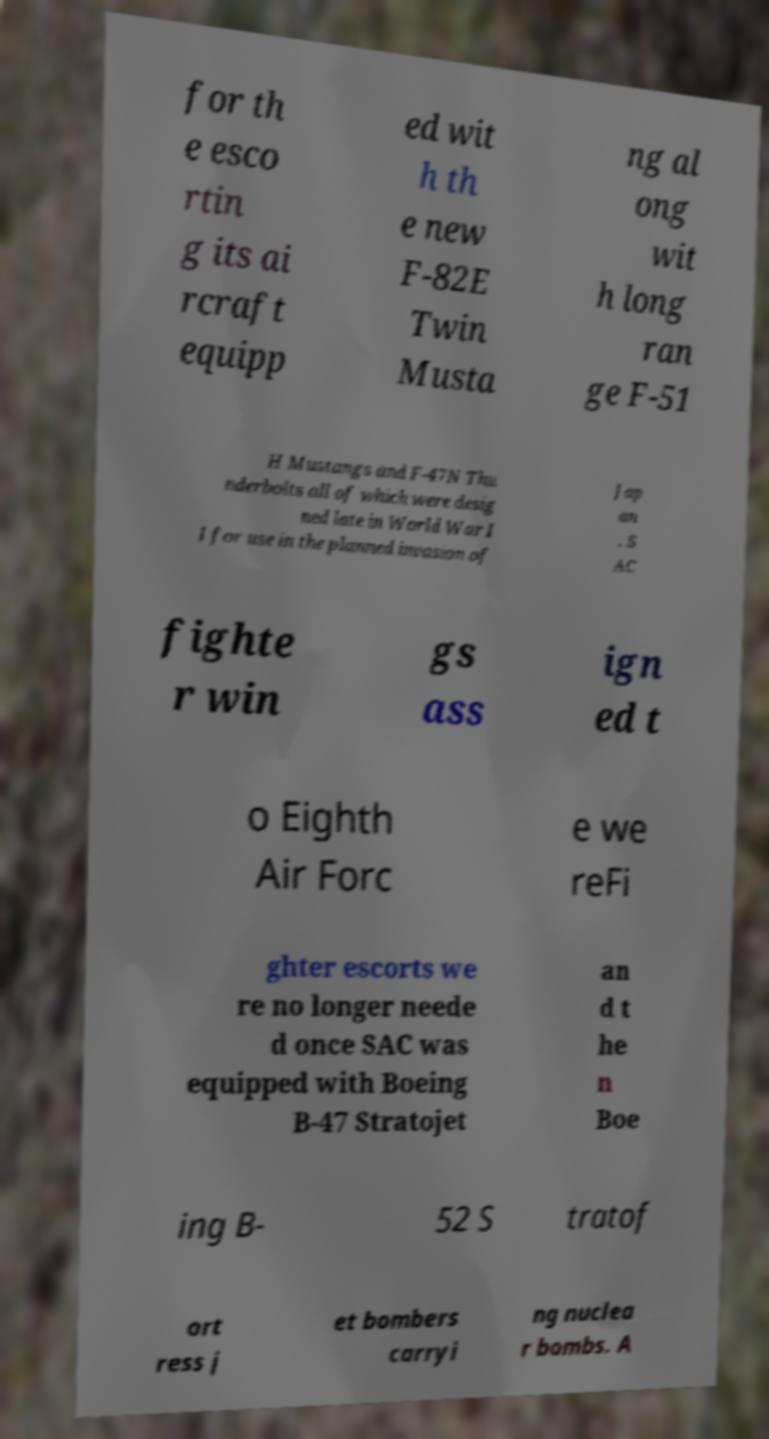Please identify and transcribe the text found in this image. for th e esco rtin g its ai rcraft equipp ed wit h th e new F-82E Twin Musta ng al ong wit h long ran ge F-51 H Mustangs and F-47N Thu nderbolts all of which were desig ned late in World War I I for use in the planned invasion of Jap an . S AC fighte r win gs ass ign ed t o Eighth Air Forc e we reFi ghter escorts we re no longer neede d once SAC was equipped with Boeing B-47 Stratojet an d t he n Boe ing B- 52 S tratof ort ress j et bombers carryi ng nuclea r bombs. A 